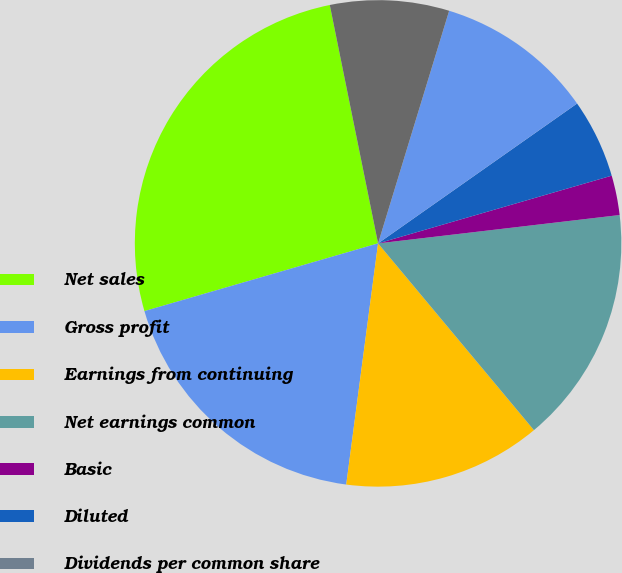Convert chart to OTSL. <chart><loc_0><loc_0><loc_500><loc_500><pie_chart><fcel>Net sales<fcel>Gross profit<fcel>Earnings from continuing<fcel>Net earnings common<fcel>Basic<fcel>Diluted<fcel>Dividends per common share<fcel>High<fcel>Low<nl><fcel>26.31%<fcel>18.42%<fcel>13.16%<fcel>15.79%<fcel>2.63%<fcel>5.26%<fcel>0.0%<fcel>10.53%<fcel>7.9%<nl></chart> 